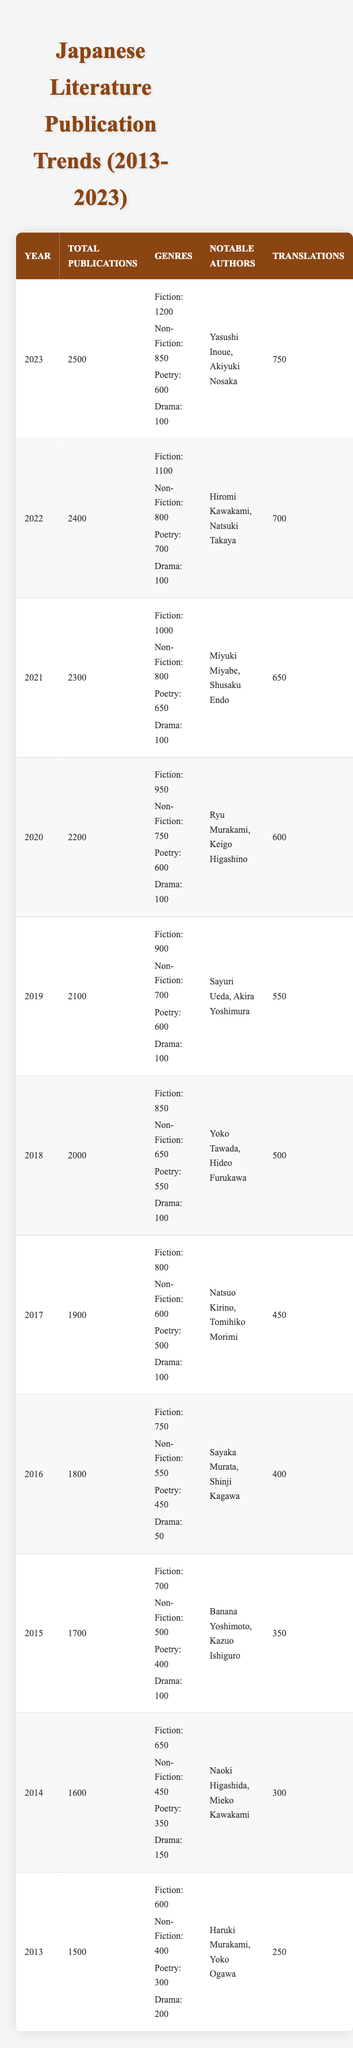What was the total number of publications in 2020? The table shows a row for the year 2020, which indicates a total of 2200 publications.
Answer: 2200 How many genres are listed for the year 2023? In the row for 2023, there are four genres mentioned: Fiction, Non-Fiction, Poetry, and Drama.
Answer: 4 Which year had the highest number of translations? By reviewing the translations column, 2023 has the highest number of translations at 750.
Answer: 2023 What is the difference in total publications between 2013 and 2023? The total publications for 2013 is 1500, and for 2023 is 2500. The difference is 2500 - 1500 = 1000.
Answer: 1000 What is the average number of translations from 2013 to 2023? The total translations from 2013 to 2023 can be summed: 250 + 300 + 350 + 400 + 450 + 500 + 550 + 600 + 650 + 700 + 750 = 5250. There are 11 years, so the average is 5250 / 11 ≈ 477.27.
Answer: 477.27 Did the publication count in 2016 exceed that in 2015? The total publications for 2016 is 1800 and for 2015 is 1700. Since 1800 is greater than 1700, the statement is true.
Answer: Yes What was the highest number of fiction publications in a single year? The year with the highest number of fiction publications is 2023, with 1200 fiction publications noted.
Answer: 1200 Which author's works were published in 2019 and what genre did they primarily represent? In 2019, Sayuri Ueda and Akira Yoshimura are the notable authors mentioned. The primary genre for both authors can be inferred through the large number of fiction publications in that year, which was 900.
Answer: Fiction How does the total number of publications in 2022 compare to that in 2021? The total publications for 2021 is 2300 and for 2022 is 2400. Since 2400 > 2300, 2022 had more publications.
Answer: 2022 had more publications In which year did the number of drama publications first fall below 100? By reviewing the drama publications from year to year, drama publications fell to 50 in 2016, which was the first occurrence.
Answer: 2016 Calculate the total number of non-fiction publications from 2014 to 2022. The non-fiction publications by year are: 450 (2014) + 500 (2015) + 550 (2016) + 600 (2017) + 650 (2018) + 700 (2019) + 750 (2020) + 800 (2021) + 800 (2022) = 5050.
Answer: 5050 